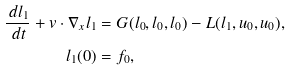<formula> <loc_0><loc_0><loc_500><loc_500>\frac { \, d l _ { 1 } } { \, d t } + v \cdot \nabla _ { x } l _ { 1 } & = G ( l _ { 0 } , l _ { 0 } , l _ { 0 } ) - L ( l _ { 1 } , u _ { 0 } , u _ { 0 } ) , \\ l _ { 1 } ( 0 ) & = f _ { 0 } ,</formula> 